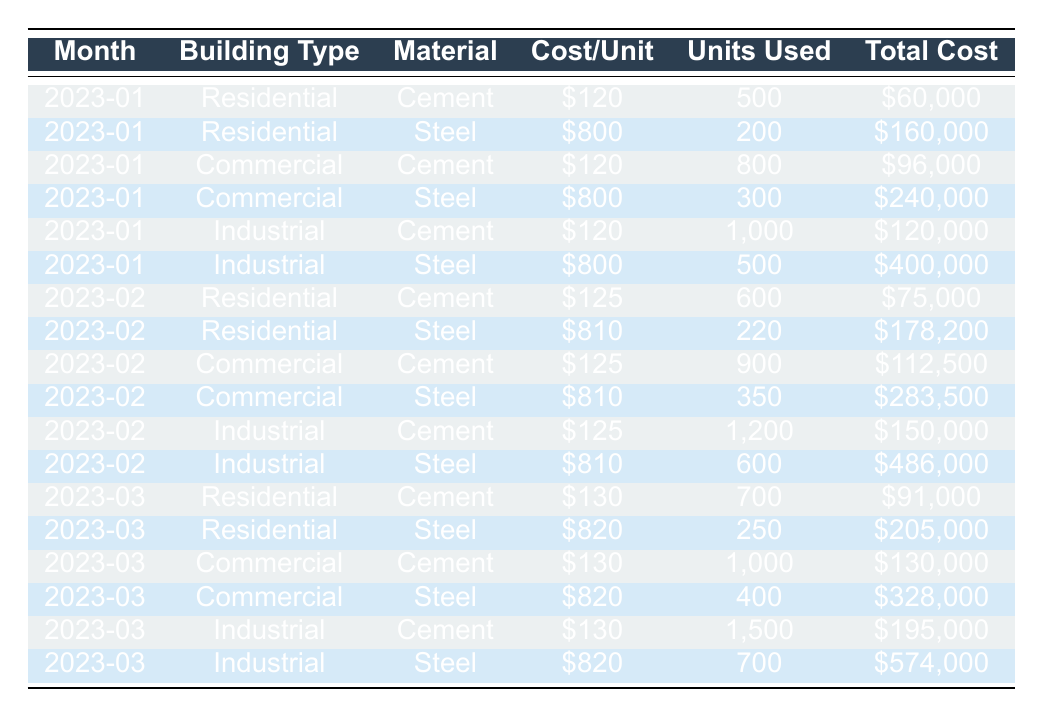What was the total cost of steel used in commercial buildings in January 2023? From the table, for commercial buildings in January 2023, the total cost of steel is listed as \$240,000.
Answer: \$240,000 How many units of cement were used in industrial buildings in February 2023? The table shows that in February 2023, industrial buildings used 1,200 units of cement.
Answer: 1,200 Which month saw the highest total cost for residential buildings? To find this, I’ll look at the total costs for residential buildings across January, February, and March 2023: January \$60,000 + \$160,000; February \$75,000 + \$178,200; March \$91,000 + \$205,000. Adding these gives totals of January \$220,000, February \$253,200, and March \$296,000. March has the highest total cost.
Answer: March What was the average cost per unit of steel for all building types across the three months? The cost per unit of steel from the data for each month and type is: January \$800 + \$800 + \$800 = \$2,400, February \$810 + \$810 + \$810 = \$2,430, March \$820 + \$820 + \$820 = \$2,460. The total cost per unit for 3 months is \$7,290, and dividing this by 3 gives an average of \$2,430.
Answer: \$810 Did the total cost of cement increase from January 2023 to March 2023 for residential buildings? In January 2023, residential cement cost was \$60,000. By March 2023, the cost had risen to \$91,000. Since \$91,000 is greater than \$60,000, the total cost increased.
Answer: Yes What is the total cost of all materials used for industrial buildings in March 2023? To calculate this, I add the total costs of cement and steel for industrial buildings in March 2023: Cement cost \$195,000 and Steel cost \$574,000. Therefore, the total cost is \$195,000 + \$574,000 = \$769,000.
Answer: \$769,000 Which building type had the highest total material cost in February 2023? I must sum the total costs for each building type in February 2023: Residential total cost = \$75,000 + \$178,200 = \$253,200; Commercial total cost = \$112,500 + \$283,500 = \$396,000; Industrial total cost = \$150,000 + \$486,000 = \$636,000. Industrial has the highest total.
Answer: Industrial Was the unit cost of cement consistent across all building types in January 2023? Looking at the table, the unit cost of cement is \$120 for all building types in January 2023. Therefore, it was consistent.
Answer: Yes How much more was spent on steel in industrial buildings compared to residential buildings in January 2023? For January 2023, the total cost of steel in industrial buildings is \$400,000 and for residential buildings it's \$160,000. The difference is \$400,000 - \$160,000 = \$240,000.
Answer: \$240,000 